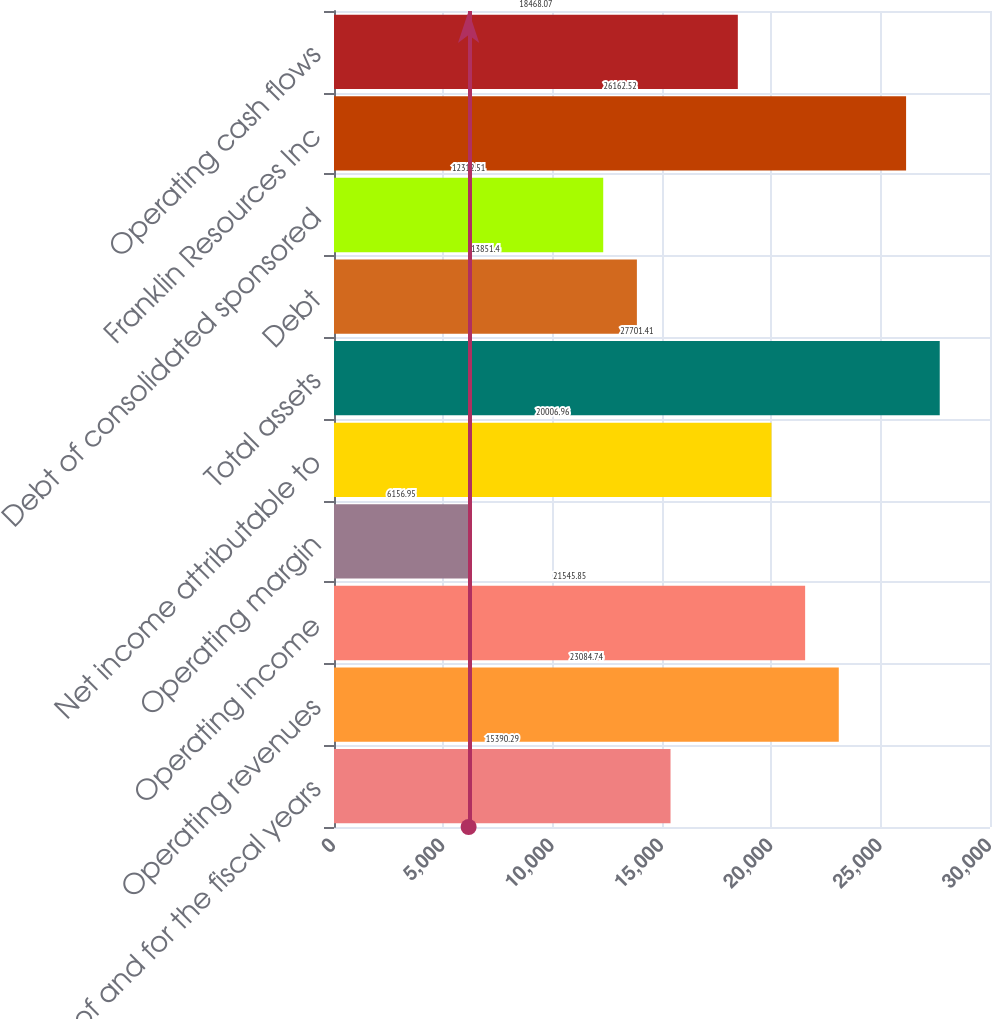Convert chart to OTSL. <chart><loc_0><loc_0><loc_500><loc_500><bar_chart><fcel>as of and for the fiscal years<fcel>Operating revenues<fcel>Operating income<fcel>Operating margin<fcel>Net income attributable to<fcel>Total assets<fcel>Debt<fcel>Debt of consolidated sponsored<fcel>Franklin Resources Inc<fcel>Operating cash flows<nl><fcel>15390.3<fcel>23084.7<fcel>21545.8<fcel>6156.95<fcel>20007<fcel>27701.4<fcel>13851.4<fcel>12312.5<fcel>26162.5<fcel>18468.1<nl></chart> 